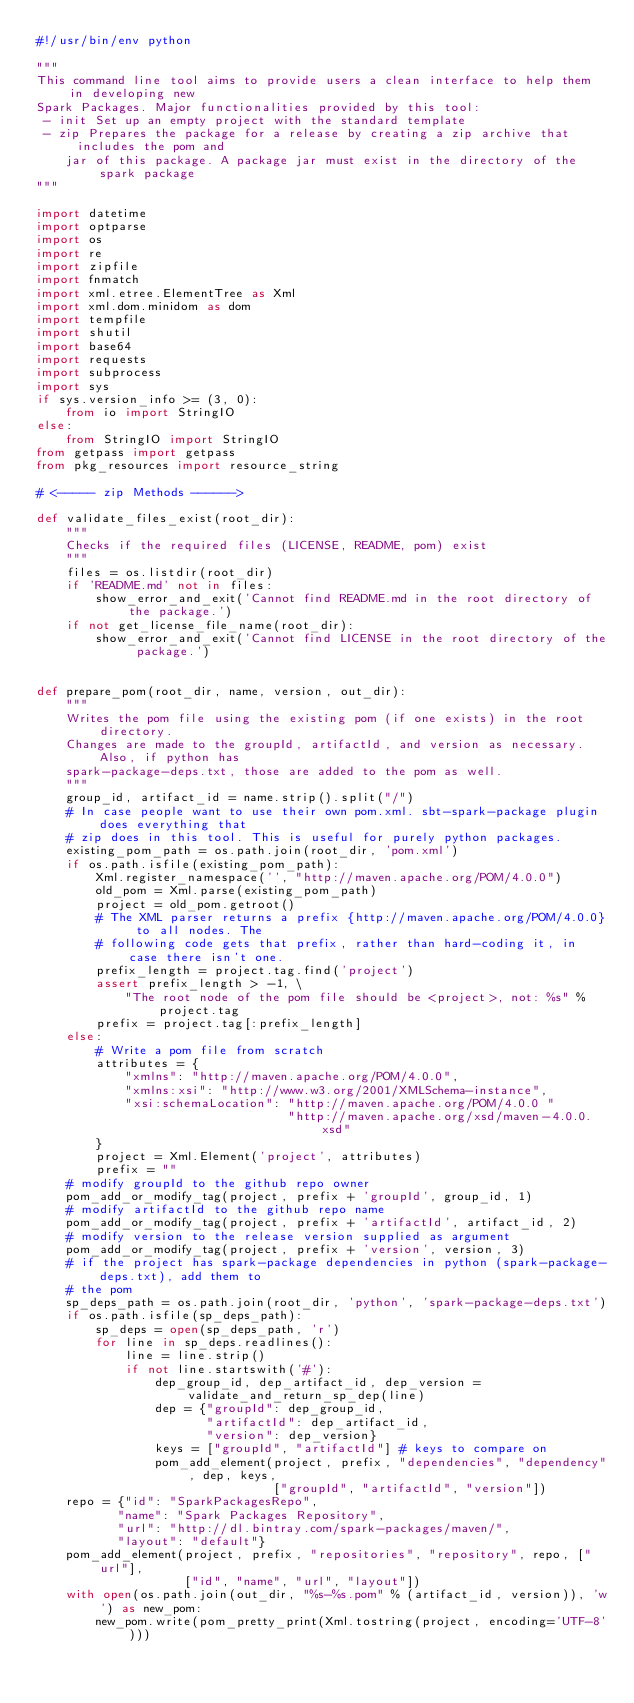Convert code to text. <code><loc_0><loc_0><loc_500><loc_500><_Python_>#!/usr/bin/env python

"""
This command line tool aims to provide users a clean interface to help them in developing new
Spark Packages. Major functionalities provided by this tool:
 - init Set up an empty project with the standard template
 - zip Prepares the package for a release by creating a zip archive that includes the pom and
    jar of this package. A package jar must exist in the directory of the spark package
"""

import datetime
import optparse
import os
import re
import zipfile
import fnmatch
import xml.etree.ElementTree as Xml
import xml.dom.minidom as dom
import tempfile
import shutil
import base64
import requests
import subprocess
import sys
if sys.version_info >= (3, 0):
    from io import StringIO
else:
    from StringIO import StringIO
from getpass import getpass
from pkg_resources import resource_string

# <----- zip Methods ------>

def validate_files_exist(root_dir):
    """
    Checks if the required files (LICENSE, README, pom) exist
    """
    files = os.listdir(root_dir)
    if 'README.md' not in files:
        show_error_and_exit('Cannot find README.md in the root directory of the package.')
    if not get_license_file_name(root_dir):
        show_error_and_exit('Cannot find LICENSE in the root directory of the package.')


def prepare_pom(root_dir, name, version, out_dir):
    """
    Writes the pom file using the existing pom (if one exists) in the root directory.
    Changes are made to the groupId, artifactId, and version as necessary. Also, if python has
    spark-package-deps.txt, those are added to the pom as well.
    """
    group_id, artifact_id = name.strip().split("/")
    # In case people want to use their own pom.xml. sbt-spark-package plugin does everything that
    # zip does in this tool. This is useful for purely python packages.
    existing_pom_path = os.path.join(root_dir, 'pom.xml')
    if os.path.isfile(existing_pom_path):
        Xml.register_namespace('', "http://maven.apache.org/POM/4.0.0")
        old_pom = Xml.parse(existing_pom_path)
        project = old_pom.getroot()
        # The XML parser returns a prefix {http://maven.apache.org/POM/4.0.0} to all nodes. The
        # following code gets that prefix, rather than hard-coding it, in case there isn't one.
        prefix_length = project.tag.find('project')
        assert prefix_length > -1, \
            "The root node of the pom file should be <project>, not: %s" % project.tag
        prefix = project.tag[:prefix_length]
    else:
        # Write a pom file from scratch
        attributes = {
            "xmlns": "http://maven.apache.org/POM/4.0.0",
            "xmlns:xsi": "http://www.w3.org/2001/XMLSchema-instance",
            "xsi:schemaLocation": "http://maven.apache.org/POM/4.0.0 "
                                  "http://maven.apache.org/xsd/maven-4.0.0.xsd"
        }
        project = Xml.Element('project', attributes)
        prefix = ""
    # modify groupId to the github repo owner
    pom_add_or_modify_tag(project, prefix + 'groupId', group_id, 1)
    # modify artifactId to the github repo name
    pom_add_or_modify_tag(project, prefix + 'artifactId', artifact_id, 2)
    # modify version to the release version supplied as argument
    pom_add_or_modify_tag(project, prefix + 'version', version, 3)
    # if the project has spark-package dependencies in python (spark-package-deps.txt), add them to
    # the pom
    sp_deps_path = os.path.join(root_dir, 'python', 'spark-package-deps.txt')
    if os.path.isfile(sp_deps_path):
        sp_deps = open(sp_deps_path, 'r')
        for line in sp_deps.readlines():
            line = line.strip()
            if not line.startswith('#'):
                dep_group_id, dep_artifact_id, dep_version = validate_and_return_sp_dep(line)
                dep = {"groupId": dep_group_id,
                       "artifactId": dep_artifact_id,
                       "version": dep_version}
                keys = ["groupId", "artifactId"] # keys to compare on
                pom_add_element(project, prefix, "dependencies", "dependency", dep, keys,
                                ["groupId", "artifactId", "version"])
    repo = {"id": "SparkPackagesRepo",
           "name": "Spark Packages Repository",
           "url": "http://dl.bintray.com/spark-packages/maven/",
           "layout": "default"}
    pom_add_element(project, prefix, "repositories", "repository", repo, ["url"],
                    ["id", "name", "url", "layout"])
    with open(os.path.join(out_dir, "%s-%s.pom" % (artifact_id, version)), 'w') as new_pom:
        new_pom.write(pom_pretty_print(Xml.tostring(project, encoding='UTF-8')))

</code> 